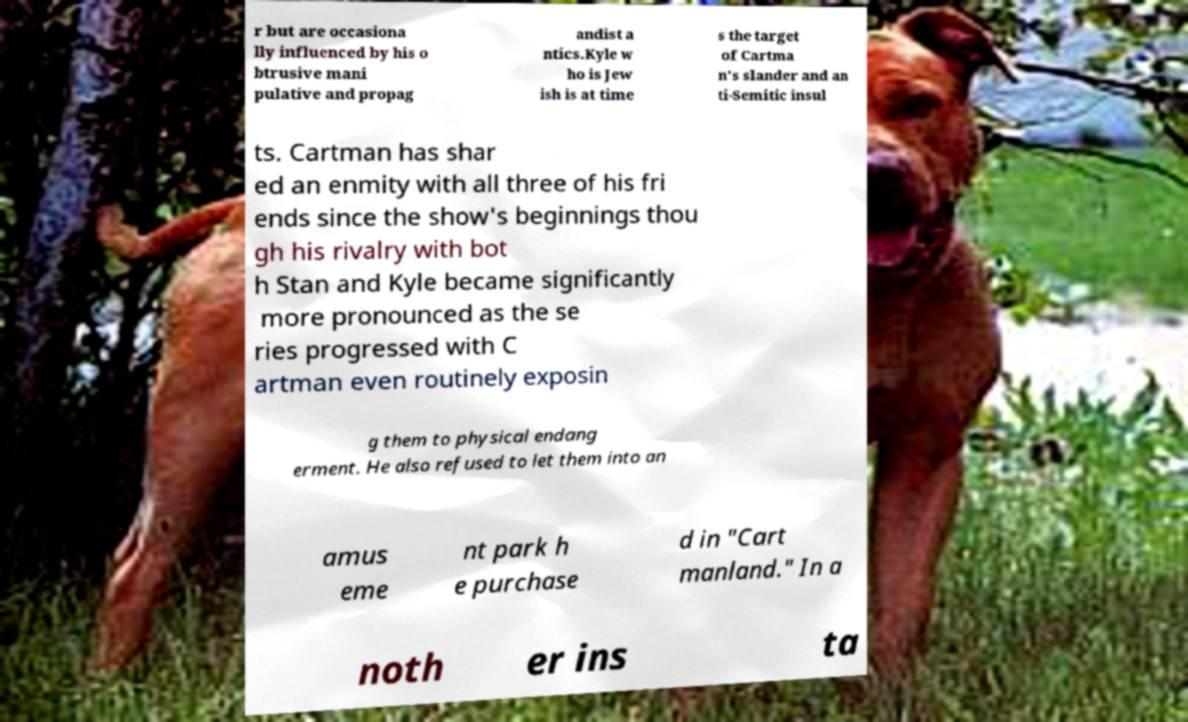Can you read and provide the text displayed in the image?This photo seems to have some interesting text. Can you extract and type it out for me? r but are occasiona lly influenced by his o btrusive mani pulative and propag andist a ntics.Kyle w ho is Jew ish is at time s the target of Cartma n's slander and an ti-Semitic insul ts. Cartman has shar ed an enmity with all three of his fri ends since the show's beginnings thou gh his rivalry with bot h Stan and Kyle became significantly more pronounced as the se ries progressed with C artman even routinely exposin g them to physical endang erment. He also refused to let them into an amus eme nt park h e purchase d in "Cart manland." In a noth er ins ta 